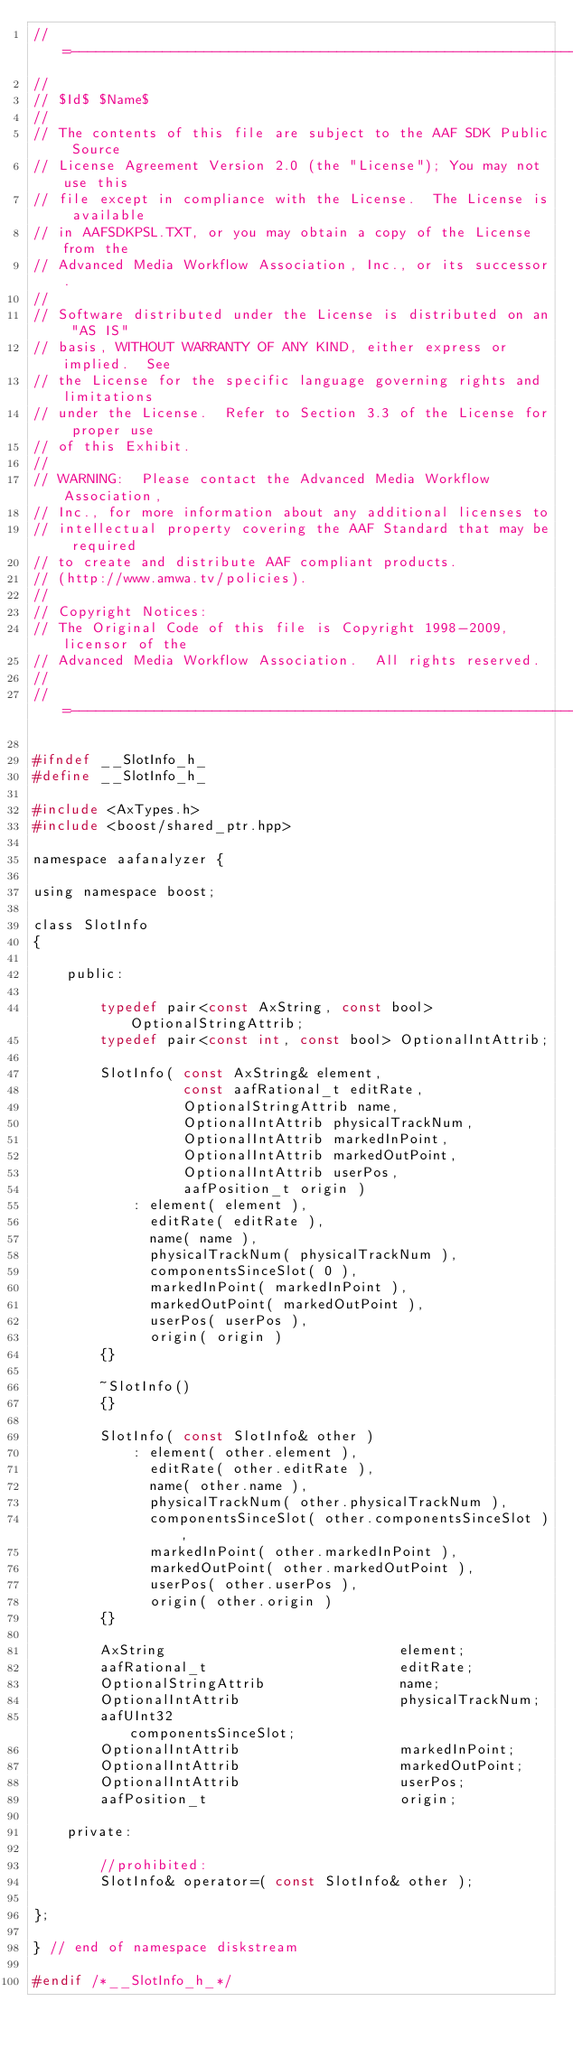Convert code to text. <code><loc_0><loc_0><loc_500><loc_500><_C_>//=---------------------------------------------------------------------=
//
// $Id$ $Name$
//
// The contents of this file are subject to the AAF SDK Public Source
// License Agreement Version 2.0 (the "License"); You may not use this
// file except in compliance with the License.  The License is available
// in AAFSDKPSL.TXT, or you may obtain a copy of the License from the
// Advanced Media Workflow Association, Inc., or its successor.
//
// Software distributed under the License is distributed on an "AS IS"
// basis, WITHOUT WARRANTY OF ANY KIND, either express or implied.  See
// the License for the specific language governing rights and limitations
// under the License.  Refer to Section 3.3 of the License for proper use
// of this Exhibit.
//
// WARNING:  Please contact the Advanced Media Workflow Association,
// Inc., for more information about any additional licenses to
// intellectual property covering the AAF Standard that may be required
// to create and distribute AAF compliant products.
// (http://www.amwa.tv/policies).
//
// Copyright Notices:
// The Original Code of this file is Copyright 1998-2009, licensor of the
// Advanced Media Workflow Association.  All rights reserved.
//
//=---------------------------------------------------------------------=

#ifndef __SlotInfo_h_
#define __SlotInfo_h_

#include <AxTypes.h>
#include <boost/shared_ptr.hpp>

namespace aafanalyzer {

using namespace boost;

class SlotInfo
{

    public:

        typedef pair<const AxString, const bool> OptionalStringAttrib;
        typedef pair<const int, const bool> OptionalIntAttrib;

        SlotInfo( const AxString& element,
                  const aafRational_t editRate,
                  OptionalStringAttrib name,
                  OptionalIntAttrib physicalTrackNum,
                  OptionalIntAttrib markedInPoint,
                  OptionalIntAttrib markedOutPoint,
                  OptionalIntAttrib userPos,
                  aafPosition_t origin )
            : element( element ),
              editRate( editRate ),
              name( name ),
              physicalTrackNum( physicalTrackNum ),
              componentsSinceSlot( 0 ),
              markedInPoint( markedInPoint ),
              markedOutPoint( markedOutPoint ),
              userPos( userPos ),
              origin( origin )
        {}

        ~SlotInfo()
        {}

        SlotInfo( const SlotInfo& other )
            : element( other.element ),
              editRate( other.editRate ),
              name( other.name ),
              physicalTrackNum( other.physicalTrackNum ),
              componentsSinceSlot( other.componentsSinceSlot ),
              markedInPoint( other.markedInPoint ),
              markedOutPoint( other.markedOutPoint ),
              userPos( other.userPos ),
              origin( other.origin )
        {}

        AxString                            element;
        aafRational_t                       editRate;
        OptionalStringAttrib                name;
        OptionalIntAttrib                   physicalTrackNum;
        aafUInt32                           componentsSinceSlot;
        OptionalIntAttrib                   markedInPoint;
        OptionalIntAttrib                   markedOutPoint;
        OptionalIntAttrib                   userPos;
        aafPosition_t                       origin;

    private:

        //prohibited:
        SlotInfo& operator=( const SlotInfo& other );

};

} // end of namespace diskstream

#endif /*__SlotInfo_h_*/
</code> 